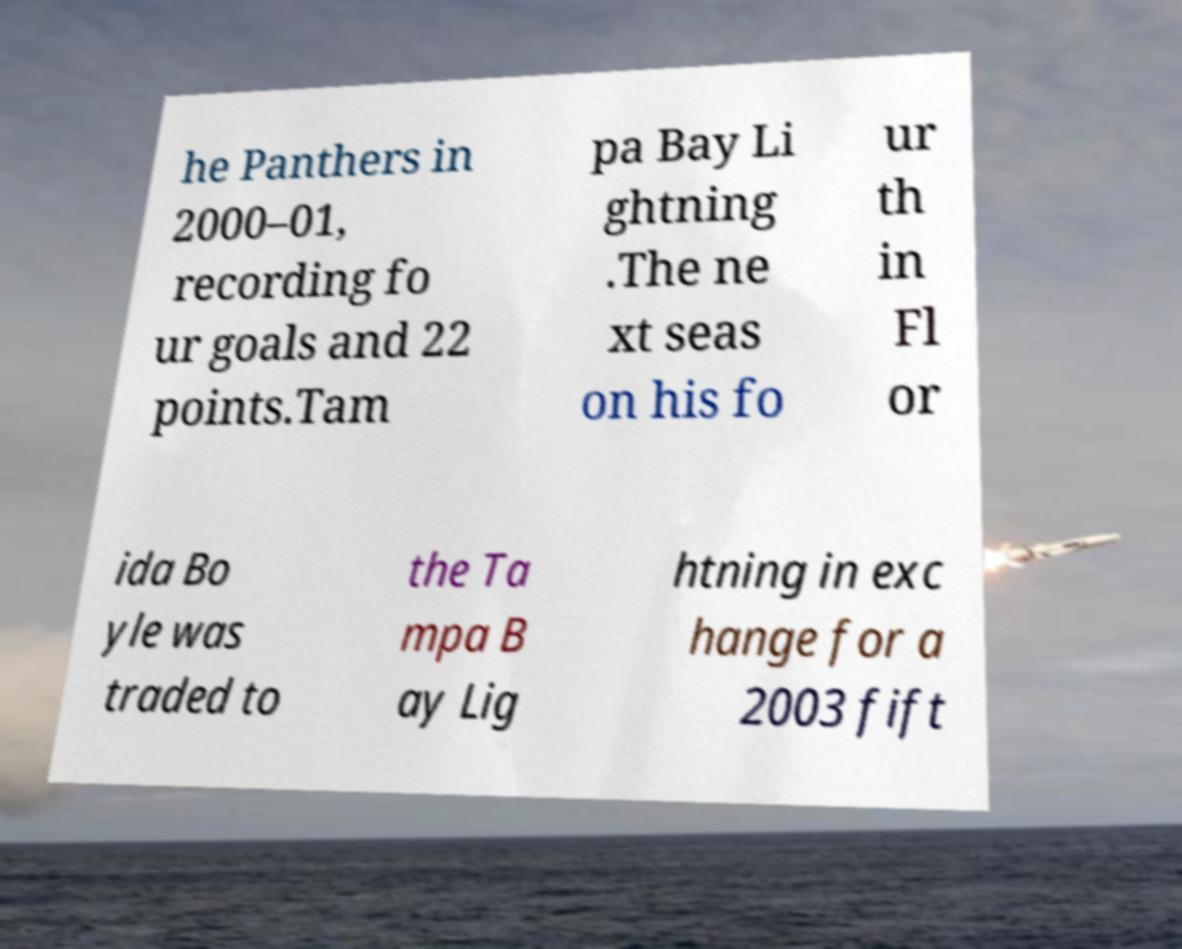Could you extract and type out the text from this image? he Panthers in 2000–01, recording fo ur goals and 22 points.Tam pa Bay Li ghtning .The ne xt seas on his fo ur th in Fl or ida Bo yle was traded to the Ta mpa B ay Lig htning in exc hange for a 2003 fift 